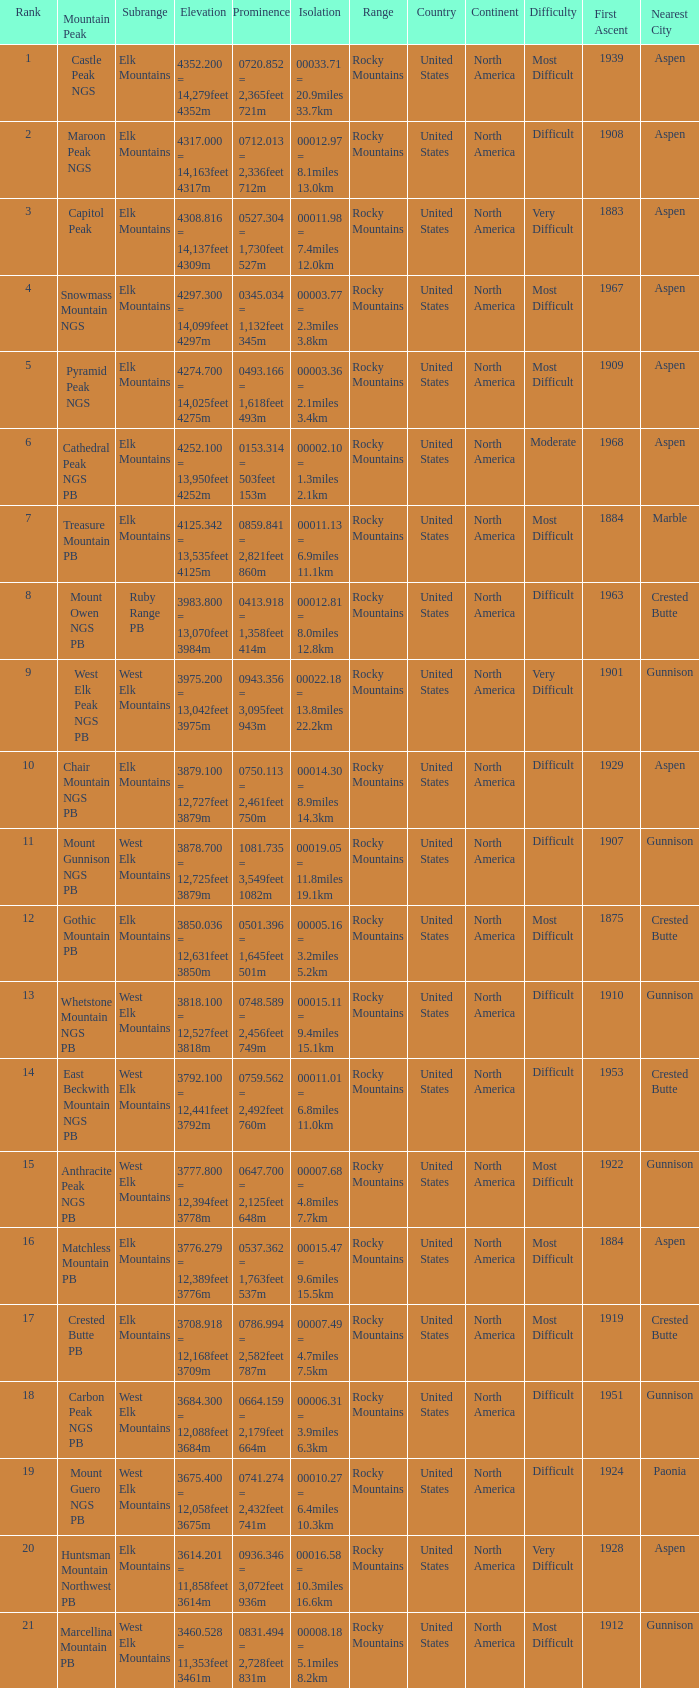Name the Prominence of the Mountain Peak of matchless mountain pb? 0537.362 = 1,763feet 537m. 